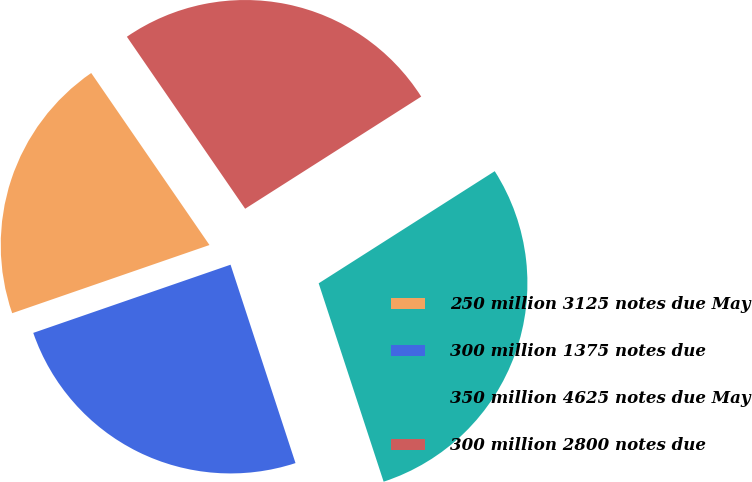Convert chart to OTSL. <chart><loc_0><loc_0><loc_500><loc_500><pie_chart><fcel>250 million 3125 notes due May<fcel>300 million 1375 notes due<fcel>350 million 4625 notes due May<fcel>300 million 2800 notes due<nl><fcel>20.71%<fcel>24.74%<fcel>28.99%<fcel>25.56%<nl></chart> 